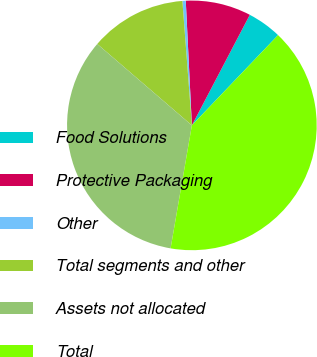Convert chart. <chart><loc_0><loc_0><loc_500><loc_500><pie_chart><fcel>Food Solutions<fcel>Protective Packaging<fcel>Other<fcel>Total segments and other<fcel>Assets not allocated<fcel>Total<nl><fcel>4.45%<fcel>8.46%<fcel>0.43%<fcel>12.48%<fcel>33.58%<fcel>40.59%<nl></chart> 